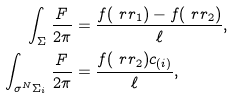Convert formula to latex. <formula><loc_0><loc_0><loc_500><loc_500>\int _ { \Sigma } \frac { F } { 2 \pi } & = \frac { f ( \ r r _ { 1 } ) - f ( \ r r _ { 2 } ) } { \ell } , \\ \int _ { \sigma ^ { N } \Sigma _ { i } } \frac { F } { 2 \pi } & = \frac { f ( \ r r _ { 2 } ) c _ { ( i ) } } { \ell } ,</formula> 